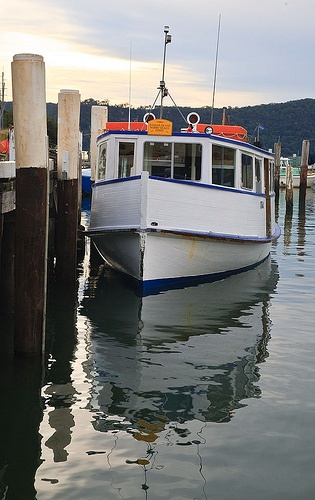Describe the objects in this image and their specific colors. I can see boat in ivory, darkgray, lightgray, black, and gray tones and boat in ivory, darkgray, gray, and black tones in this image. 